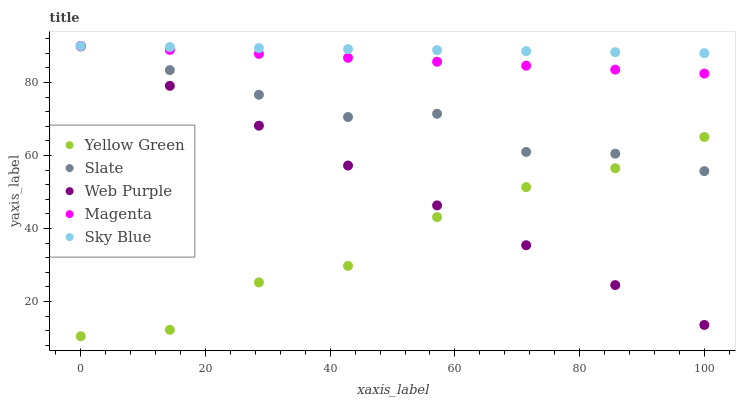Does Yellow Green have the minimum area under the curve?
Answer yes or no. Yes. Does Sky Blue have the maximum area under the curve?
Answer yes or no. Yes. Does Slate have the minimum area under the curve?
Answer yes or no. No. Does Slate have the maximum area under the curve?
Answer yes or no. No. Is Sky Blue the smoothest?
Answer yes or no. Yes. Is Yellow Green the roughest?
Answer yes or no. Yes. Is Slate the smoothest?
Answer yes or no. No. Is Slate the roughest?
Answer yes or no. No. Does Yellow Green have the lowest value?
Answer yes or no. Yes. Does Slate have the lowest value?
Answer yes or no. No. Does Sky Blue have the highest value?
Answer yes or no. Yes. Does Slate have the highest value?
Answer yes or no. No. Is Slate less than Magenta?
Answer yes or no. Yes. Is Sky Blue greater than Yellow Green?
Answer yes or no. Yes. Does Web Purple intersect Yellow Green?
Answer yes or no. Yes. Is Web Purple less than Yellow Green?
Answer yes or no. No. Is Web Purple greater than Yellow Green?
Answer yes or no. No. Does Slate intersect Magenta?
Answer yes or no. No. 